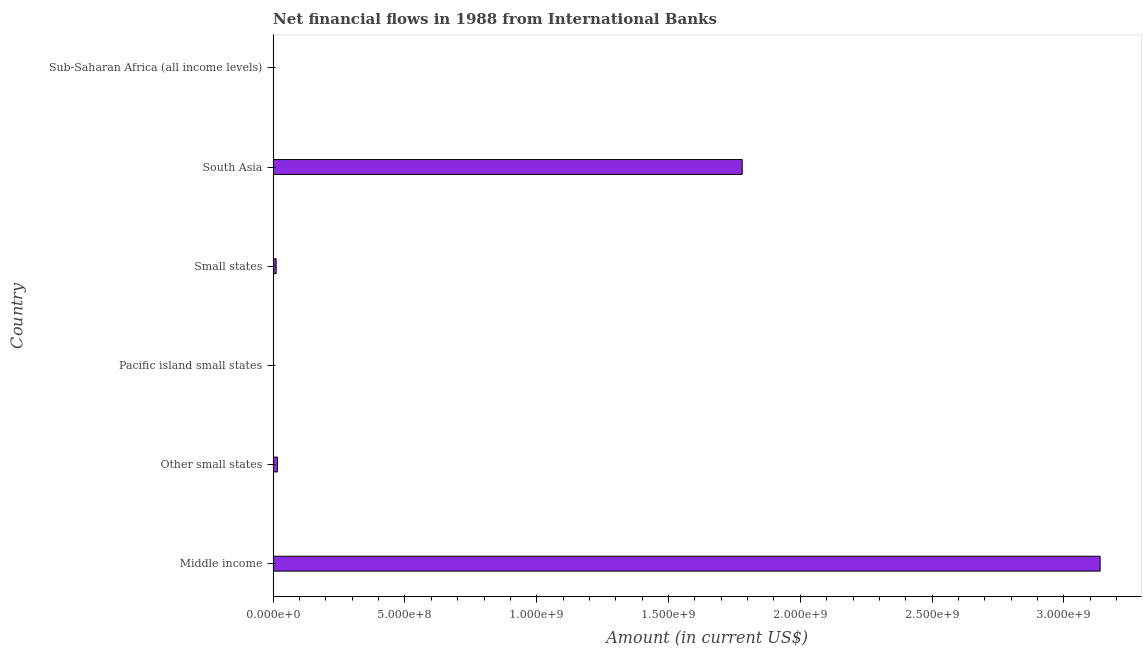Does the graph contain grids?
Your response must be concise. No. What is the title of the graph?
Your answer should be very brief. Net financial flows in 1988 from International Banks. What is the label or title of the Y-axis?
Give a very brief answer. Country. What is the net financial flows from ibrd in Middle income?
Your answer should be compact. 3.14e+09. Across all countries, what is the maximum net financial flows from ibrd?
Make the answer very short. 3.14e+09. Across all countries, what is the minimum net financial flows from ibrd?
Keep it short and to the point. 0. In which country was the net financial flows from ibrd maximum?
Your answer should be compact. Middle income. What is the sum of the net financial flows from ibrd?
Your response must be concise. 4.94e+09. What is the difference between the net financial flows from ibrd in Other small states and South Asia?
Give a very brief answer. -1.76e+09. What is the average net financial flows from ibrd per country?
Give a very brief answer. 8.24e+08. What is the median net financial flows from ibrd?
Provide a succinct answer. 1.39e+07. In how many countries, is the net financial flows from ibrd greater than 2800000000 US$?
Offer a terse response. 1. Is the net financial flows from ibrd in Other small states less than that in Small states?
Keep it short and to the point. No. Is the difference between the net financial flows from ibrd in Middle income and South Asia greater than the difference between any two countries?
Offer a terse response. No. What is the difference between the highest and the second highest net financial flows from ibrd?
Provide a succinct answer. 1.36e+09. Is the sum of the net financial flows from ibrd in Middle income and Small states greater than the maximum net financial flows from ibrd across all countries?
Make the answer very short. Yes. What is the difference between the highest and the lowest net financial flows from ibrd?
Make the answer very short. 3.14e+09. In how many countries, is the net financial flows from ibrd greater than the average net financial flows from ibrd taken over all countries?
Offer a very short reply. 2. How many bars are there?
Your answer should be very brief. 4. What is the difference between two consecutive major ticks on the X-axis?
Your answer should be very brief. 5.00e+08. What is the Amount (in current US$) in Middle income?
Your answer should be very brief. 3.14e+09. What is the Amount (in current US$) of Other small states?
Provide a succinct answer. 1.64e+07. What is the Amount (in current US$) of Small states?
Your answer should be compact. 1.14e+07. What is the Amount (in current US$) of South Asia?
Offer a very short reply. 1.78e+09. What is the difference between the Amount (in current US$) in Middle income and Other small states?
Provide a succinct answer. 3.12e+09. What is the difference between the Amount (in current US$) in Middle income and Small states?
Ensure brevity in your answer.  3.13e+09. What is the difference between the Amount (in current US$) in Middle income and South Asia?
Provide a succinct answer. 1.36e+09. What is the difference between the Amount (in current US$) in Other small states and Small states?
Your response must be concise. 5.00e+06. What is the difference between the Amount (in current US$) in Other small states and South Asia?
Ensure brevity in your answer.  -1.76e+09. What is the difference between the Amount (in current US$) in Small states and South Asia?
Your response must be concise. -1.77e+09. What is the ratio of the Amount (in current US$) in Middle income to that in Other small states?
Give a very brief answer. 191.07. What is the ratio of the Amount (in current US$) in Middle income to that in Small states?
Provide a short and direct response. 274.8. What is the ratio of the Amount (in current US$) in Middle income to that in South Asia?
Your answer should be compact. 1.76. What is the ratio of the Amount (in current US$) in Other small states to that in Small states?
Give a very brief answer. 1.44. What is the ratio of the Amount (in current US$) in Other small states to that in South Asia?
Provide a short and direct response. 0.01. What is the ratio of the Amount (in current US$) in Small states to that in South Asia?
Offer a terse response. 0.01. 